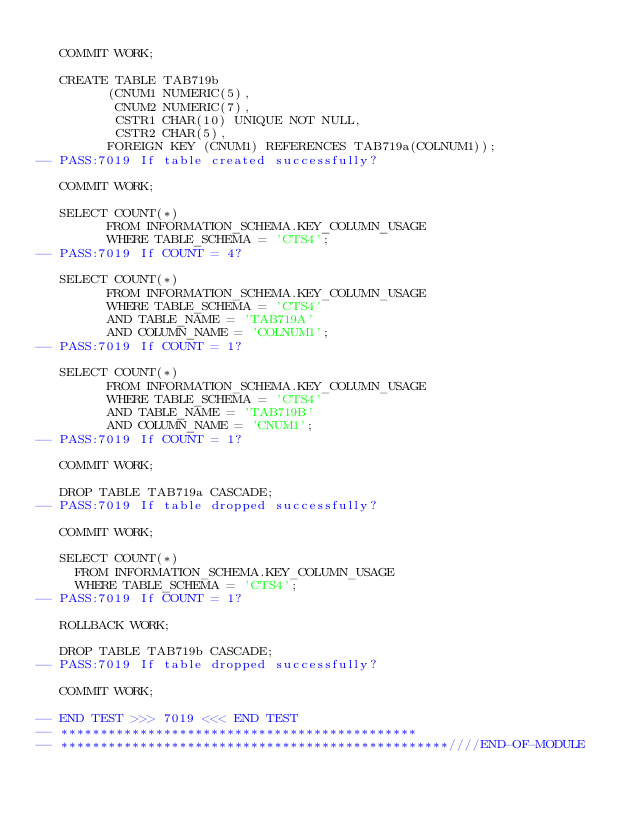<code> <loc_0><loc_0><loc_500><loc_500><_SQL_>
   COMMIT WORK;

   CREATE TABLE TAB719b
         (CNUM1 NUMERIC(5),
          CNUM2 NUMERIC(7), 
          CSTR1 CHAR(10) UNIQUE NOT NULL,
          CSTR2 CHAR(5),
         FOREIGN KEY (CNUM1) REFERENCES TAB719a(COLNUM1));
-- PASS:7019 If table created successfully?

   COMMIT WORK;

   SELECT COUNT(*) 
         FROM INFORMATION_SCHEMA.KEY_COLUMN_USAGE
         WHERE TABLE_SCHEMA = 'CTS4';
-- PASS:7019 If COUNT = 4?

   SELECT COUNT(*) 
         FROM INFORMATION_SCHEMA.KEY_COLUMN_USAGE
         WHERE TABLE_SCHEMA = 'CTS4'
         AND TABLE_NAME = 'TAB719A'
         AND COLUMN_NAME = 'COLNUM1';
-- PASS:7019 If COUNT = 1?

   SELECT COUNT(*) 
         FROM INFORMATION_SCHEMA.KEY_COLUMN_USAGE
         WHERE TABLE_SCHEMA = 'CTS4'
         AND TABLE_NAME = 'TAB719B'
         AND COLUMN_NAME = 'CNUM1';
-- PASS:7019 If COUNT = 1?

   COMMIT WORK;

   DROP TABLE TAB719a CASCADE;
-- PASS:7019 If table dropped successfully?

   COMMIT WORK;

   SELECT COUNT(*)
     FROM INFORMATION_SCHEMA.KEY_COLUMN_USAGE
     WHERE TABLE_SCHEMA = 'CTS4';
-- PASS:7019 If COUNT = 1?

   ROLLBACK WORK;

   DROP TABLE TAB719b CASCADE;
-- PASS:7019 If table dropped successfully?

   COMMIT WORK;

-- END TEST >>> 7019 <<< END TEST
-- *********************************************
-- *************************************************////END-OF-MODULE
</code> 